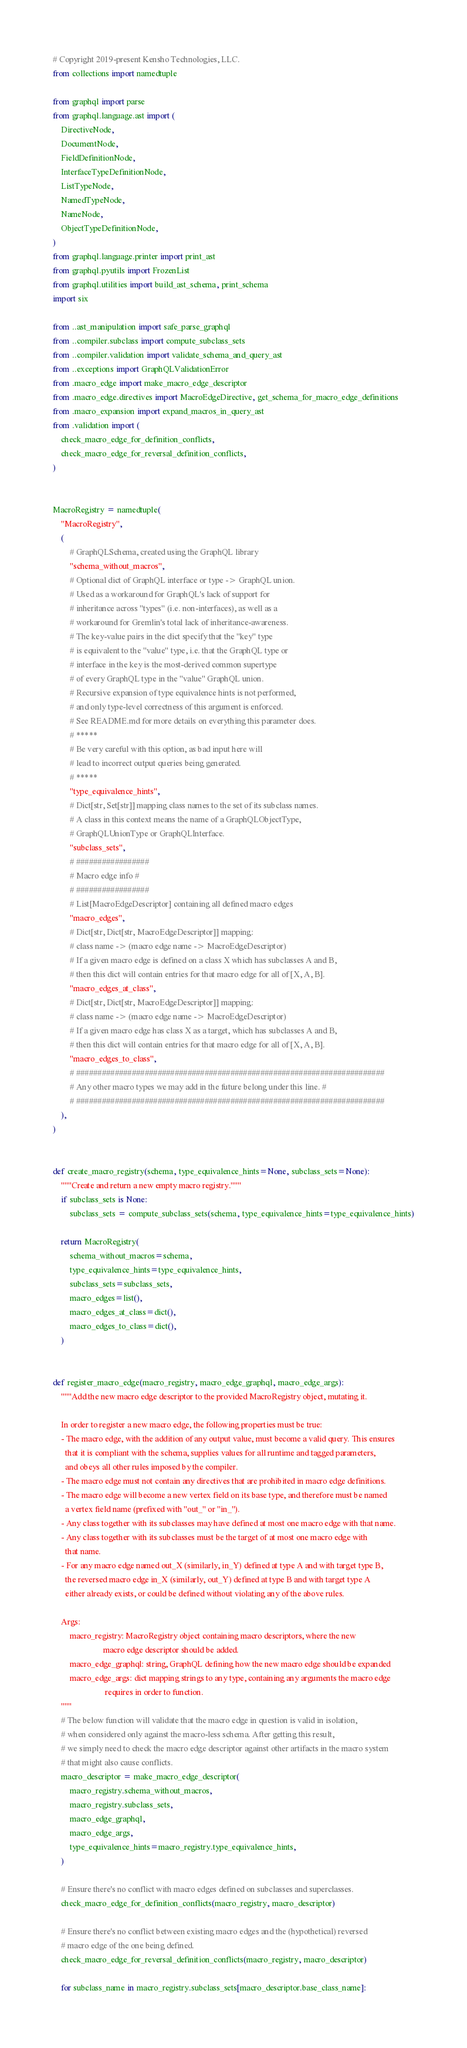<code> <loc_0><loc_0><loc_500><loc_500><_Python_># Copyright 2019-present Kensho Technologies, LLC.
from collections import namedtuple

from graphql import parse
from graphql.language.ast import (
    DirectiveNode,
    DocumentNode,
    FieldDefinitionNode,
    InterfaceTypeDefinitionNode,
    ListTypeNode,
    NamedTypeNode,
    NameNode,
    ObjectTypeDefinitionNode,
)
from graphql.language.printer import print_ast
from graphql.pyutils import FrozenList
from graphql.utilities import build_ast_schema, print_schema
import six

from ..ast_manipulation import safe_parse_graphql
from ..compiler.subclass import compute_subclass_sets
from ..compiler.validation import validate_schema_and_query_ast
from ..exceptions import GraphQLValidationError
from .macro_edge import make_macro_edge_descriptor
from .macro_edge.directives import MacroEdgeDirective, get_schema_for_macro_edge_definitions
from .macro_expansion import expand_macros_in_query_ast
from .validation import (
    check_macro_edge_for_definition_conflicts,
    check_macro_edge_for_reversal_definition_conflicts,
)


MacroRegistry = namedtuple(
    "MacroRegistry",
    (
        # GraphQLSchema, created using the GraphQL library
        "schema_without_macros",
        # Optional dict of GraphQL interface or type -> GraphQL union.
        # Used as a workaround for GraphQL's lack of support for
        # inheritance across "types" (i.e. non-interfaces), as well as a
        # workaround for Gremlin's total lack of inheritance-awareness.
        # The key-value pairs in the dict specify that the "key" type
        # is equivalent to the "value" type, i.e. that the GraphQL type or
        # interface in the key is the most-derived common supertype
        # of every GraphQL type in the "value" GraphQL union.
        # Recursive expansion of type equivalence hints is not performed,
        # and only type-level correctness of this argument is enforced.
        # See README.md for more details on everything this parameter does.
        # *****
        # Be very careful with this option, as bad input here will
        # lead to incorrect output queries being generated.
        # *****
        "type_equivalence_hints",
        # Dict[str, Set[str]] mapping class names to the set of its subclass names.
        # A class in this context means the name of a GraphQLObjectType,
        # GraphQLUnionType or GraphQLInterface.
        "subclass_sets",
        # #################
        # Macro edge info #
        # #################
        # List[MacroEdgeDescriptor] containing all defined macro edges
        "macro_edges",
        # Dict[str, Dict[str, MacroEdgeDescriptor]] mapping:
        # class name -> (macro edge name -> MacroEdgeDescriptor)
        # If a given macro edge is defined on a class X which has subclasses A and B,
        # then this dict will contain entries for that macro edge for all of [X, A, B].
        "macro_edges_at_class",
        # Dict[str, Dict[str, MacroEdgeDescriptor]] mapping:
        # class name -> (macro edge name -> MacroEdgeDescriptor)
        # If a given macro edge has class X as a target, which has subclasses A and B,
        # then this dict will contain entries for that macro edge for all of [X, A, B].
        "macro_edges_to_class",
        # ########################################################################
        # Any other macro types we may add in the future belong under this line. #
        # ########################################################################
    ),
)


def create_macro_registry(schema, type_equivalence_hints=None, subclass_sets=None):
    """Create and return a new empty macro registry."""
    if subclass_sets is None:
        subclass_sets = compute_subclass_sets(schema, type_equivalence_hints=type_equivalence_hints)

    return MacroRegistry(
        schema_without_macros=schema,
        type_equivalence_hints=type_equivalence_hints,
        subclass_sets=subclass_sets,
        macro_edges=list(),
        macro_edges_at_class=dict(),
        macro_edges_to_class=dict(),
    )


def register_macro_edge(macro_registry, macro_edge_graphql, macro_edge_args):
    """Add the new macro edge descriptor to the provided MacroRegistry object, mutating it.

    In order to register a new macro edge, the following properties must be true:
    - The macro edge, with the addition of any output value, must become a valid query. This ensures
      that it is compliant with the schema, supplies values for all runtime and tagged parameters,
      and obeys all other rules imposed by the compiler.
    - The macro edge must not contain any directives that are prohibited in macro edge definitions.
    - The macro edge will become a new vertex field on its base type, and therefore must be named
      a vertex field name (prefixed with "out_" or "in_").
    - Any class together with its subclasses may have defined at most one macro edge with that name.
    - Any class together with its subclasses must be the target of at most one macro edge with
      that name.
    - For any macro edge named out_X (similarly, in_Y) defined at type A and with target type B,
      the reversed macro edge in_X (similarly, out_Y) defined at type B and with target type A
      either already exists, or could be defined without violating any of the above rules.

    Args:
        macro_registry: MacroRegistry object containing macro descriptors, where the new
                        macro edge descriptor should be added.
        macro_edge_graphql: string, GraphQL defining how the new macro edge should be expanded
        macro_edge_args: dict mapping strings to any type, containing any arguments the macro edge
                         requires in order to function.
    """
    # The below function will validate that the macro edge in question is valid in isolation,
    # when considered only against the macro-less schema. After getting this result,
    # we simply need to check the macro edge descriptor against other artifacts in the macro system
    # that might also cause conflicts.
    macro_descriptor = make_macro_edge_descriptor(
        macro_registry.schema_without_macros,
        macro_registry.subclass_sets,
        macro_edge_graphql,
        macro_edge_args,
        type_equivalence_hints=macro_registry.type_equivalence_hints,
    )

    # Ensure there's no conflict with macro edges defined on subclasses and superclasses.
    check_macro_edge_for_definition_conflicts(macro_registry, macro_descriptor)

    # Ensure there's no conflict between existing macro edges and the (hypothetical) reversed
    # macro edge of the one being defined.
    check_macro_edge_for_reversal_definition_conflicts(macro_registry, macro_descriptor)

    for subclass_name in macro_registry.subclass_sets[macro_descriptor.base_class_name]:</code> 